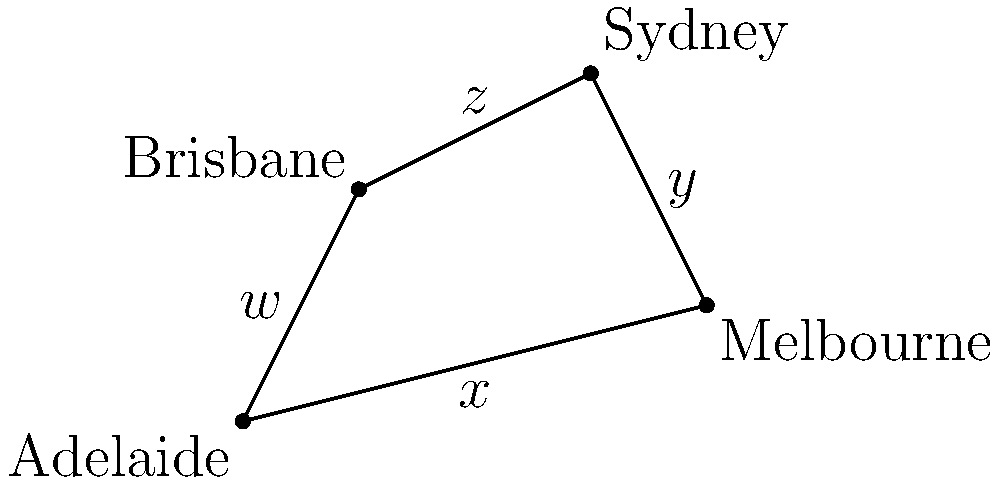John Mitchell, the renowned Australian rugby coach, is planning a national training camp. He wants to calculate the area of the region covered by connecting four major cities: Adelaide, Melbourne, Sydney, and Brisbane. Given the coordinates of these cities on a map (in arbitrary units) as Adelaide (0,0), Melbourne (8,2), Sydney (6,6), and Brisbane (2,4), calculate the area of the quadrilateral formed by connecting these points. Express your answer in square units. To solve this problem, we'll use the shoelace formula (also known as the surveyor's formula) to calculate the area of the irregular quadrilateral. Here's how we proceed:

1) The shoelace formula for a quadrilateral with vertices $(x_1,y_1)$, $(x_2,y_2)$, $(x_3,y_3)$, and $(x_4,y_4)$ is:

   Area = $\frac{1}{2}|x_1y_2 + x_2y_3 + x_3y_4 + x_4y_1 - y_1x_2 - y_2x_3 - y_3x_4 - y_4x_1|$

2) Let's assign our points:
   Adelaide: $(x_1,y_1) = (0,0)$
   Melbourne: $(x_2,y_2) = (8,2)$
   Sydney: $(x_3,y_3) = (6,6)$
   Brisbane: $(x_4,y_4) = (2,4)$

3) Now, let's substitute these into our formula:

   Area = $\frac{1}{2}|(0 \cdot 2 + 8 \cdot 6 + 6 \cdot 4 + 2 \cdot 0) - (0 \cdot 8 + 2 \cdot 6 + 6 \cdot 2 + 4 \cdot 0)|$

4) Simplify:
   Area = $\frac{1}{2}|(0 + 48 + 24 + 0) - (0 + 12 + 12 + 0)|$
   
5) Calculate:
   Area = $\frac{1}{2}|72 - 24|$
   Area = $\frac{1}{2} \cdot 48$
   Area = 24

Therefore, the area of the quadrilateral is 24 square units.
Answer: 24 square units 